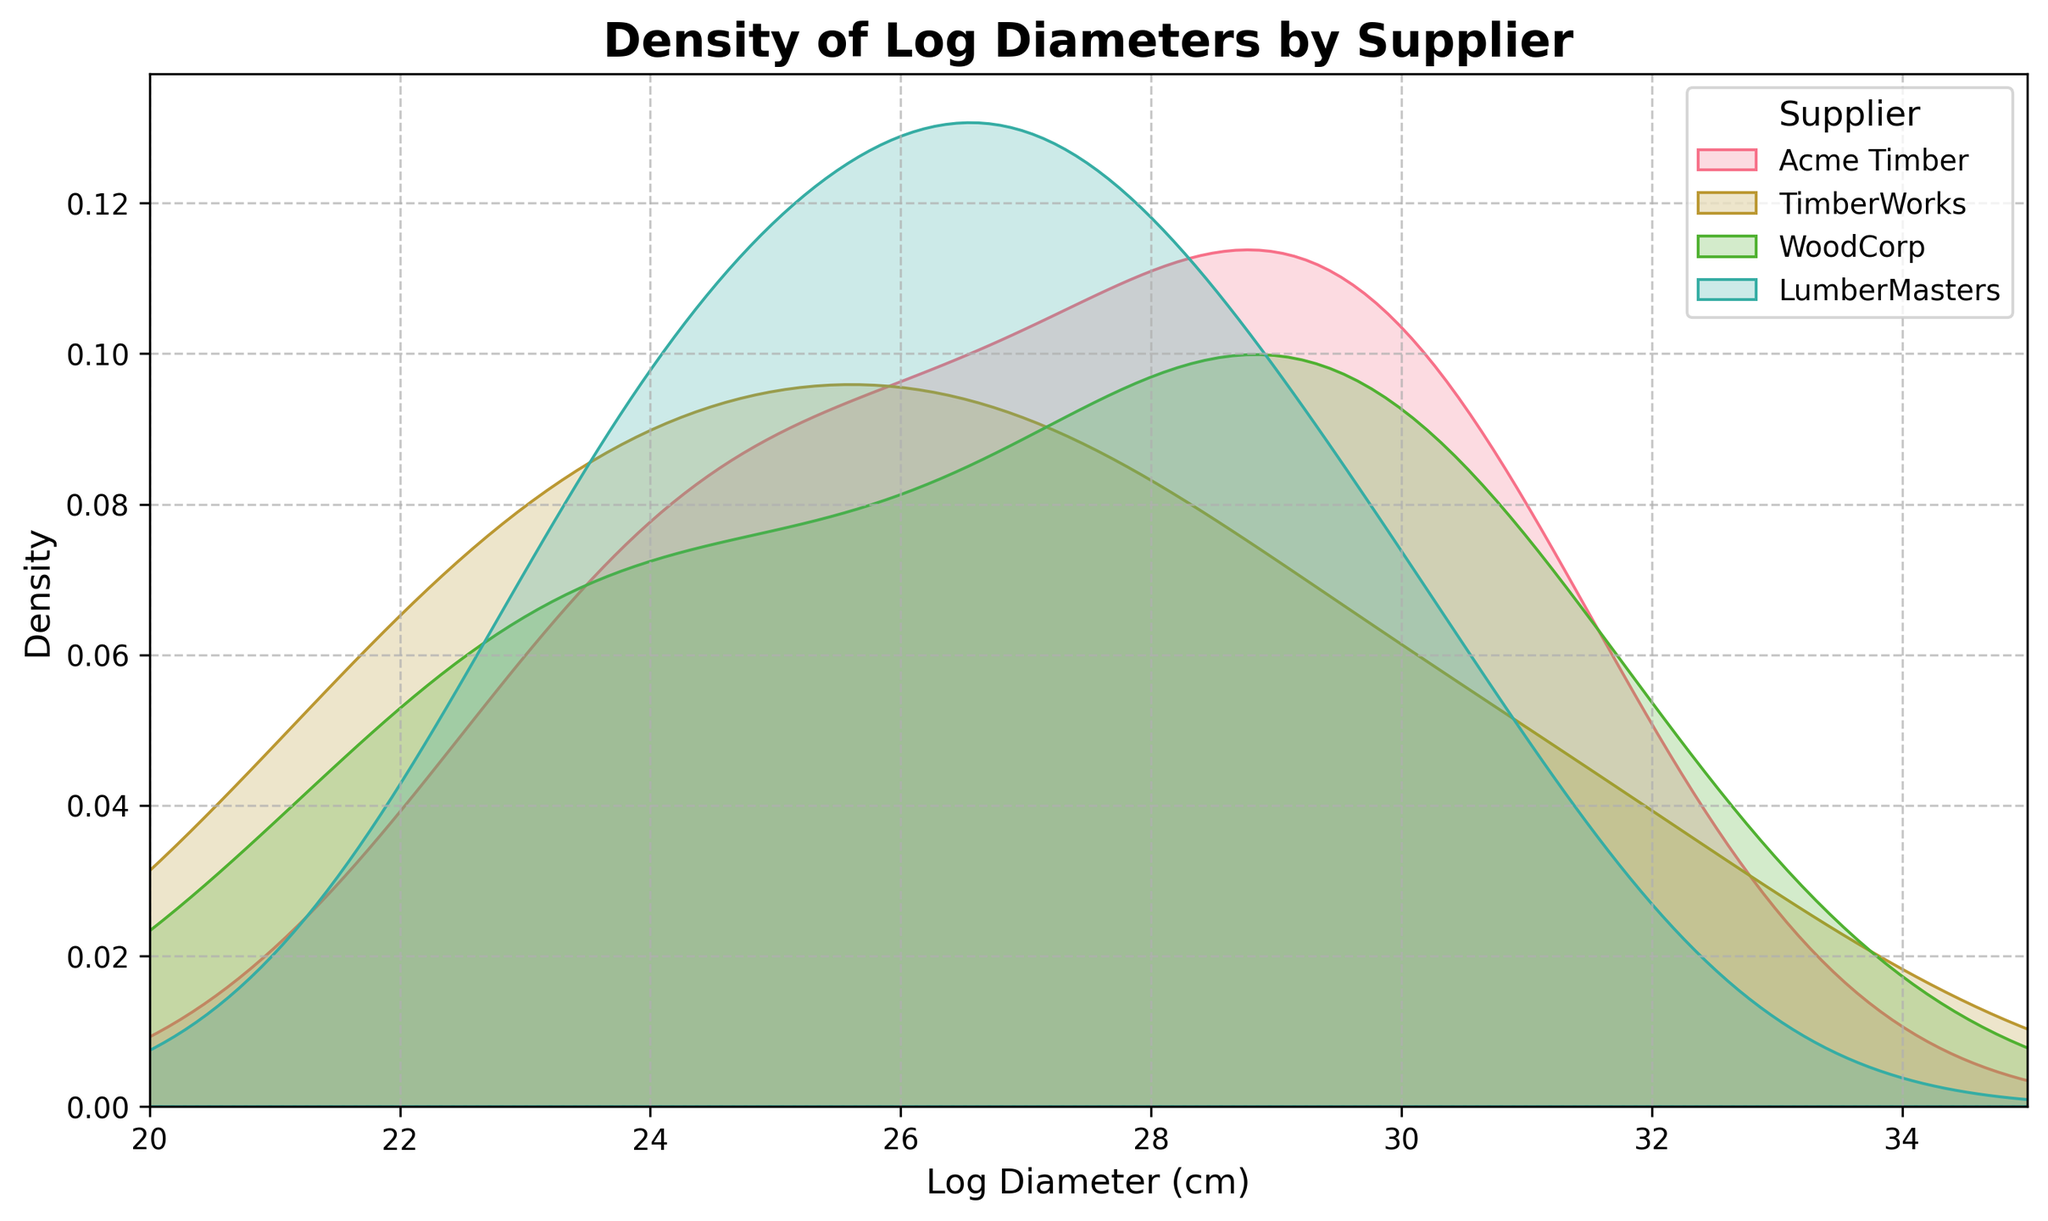What's the title of the figure? The title of the figure is located at the top center and is usually in bold.
Answer: Density of Log Diameters by Supplier Which supplier appears to have the most variability in log diameters? The supplier with the widest spread in their density curve would have the most variability in their log diameters.
Answer: TimberWorks What is the range of log diameters on the x-axis? The x-axis range can be found by looking at the tick marks at the bottom of the plot.
Answer: 20 to 35 cm Which supplier has the peak density at the smallest log diameter? Look for the density curve with the highest peak on the left side of the plot.
Answer: TimberWorks Which two suppliers have density curves that overlap the most? Identify the pairs of curves that share the most common area by visually comparing their overlap.
Answer: Acme Timber and WoodCorp What's the highest log diameter for WoodCorp based on the plot? Observe the rightmost extent of the WoodCorp density curve on the x-axis.
Answer: 30.5 cm Does LumberMasters have a more consistent log diameter compared to TimberWorks? Consistency can be inferred from the narrowness of the density curve. A narrower curve suggests more consistency. Compare the widths of LumberMasters and TimberWorks curves.
Answer: Yes Which supplier shows a high density at around 27-28 cm? Find the density curve(s) with a prominent peak in the 27-28 cm range.
Answer: Acme Timber What can be inferred about log diameter quality and reliability from the plot? Suppliers with narrower density curves suggest more consistent log diameters, which could imply better quality control and reliability. Narrow curves indicate less variability.
Answer: Narrower curves imply better quality control How does the density of log diameters from Acme Timber compare to that from WoodCorp? Compare the shape, peaks, and spread of the density curves for Acme Timber and WoodCorp to determine similarities and differences in log diameters.
Answer: Acme Timber has a broader range, WoodCorp is more consistent 